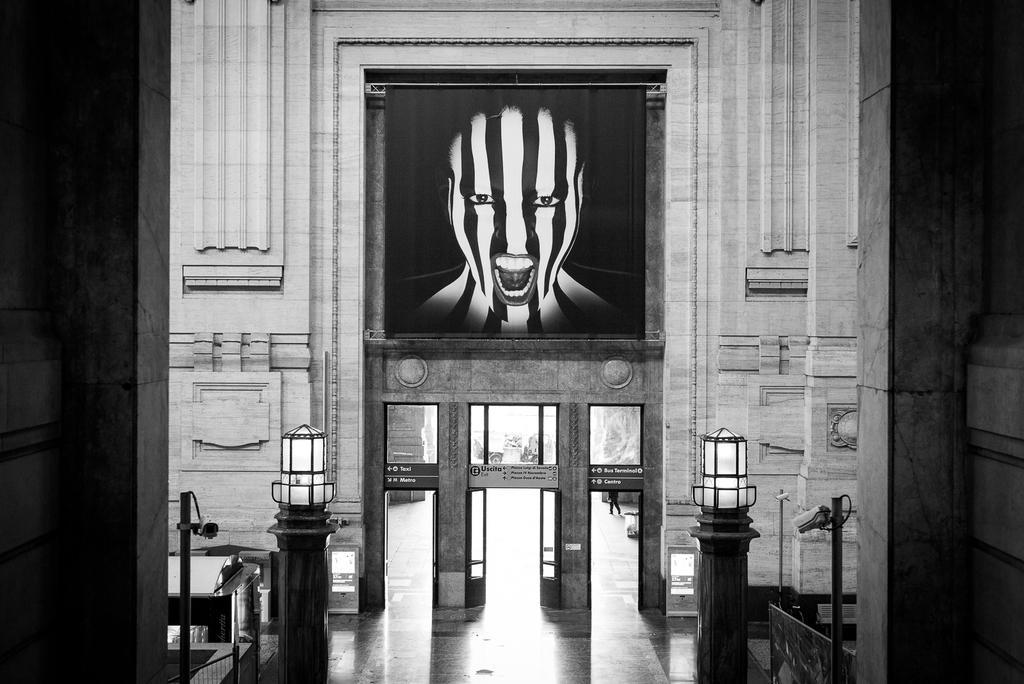In one or two sentences, can you explain what this image depicts? In this picture I can observe a wall. On either sides of the picture I can observe two lamps. There are doors in the middle of the picture. Above the doors I can observe a painting of a human face. This is a black and white image. 